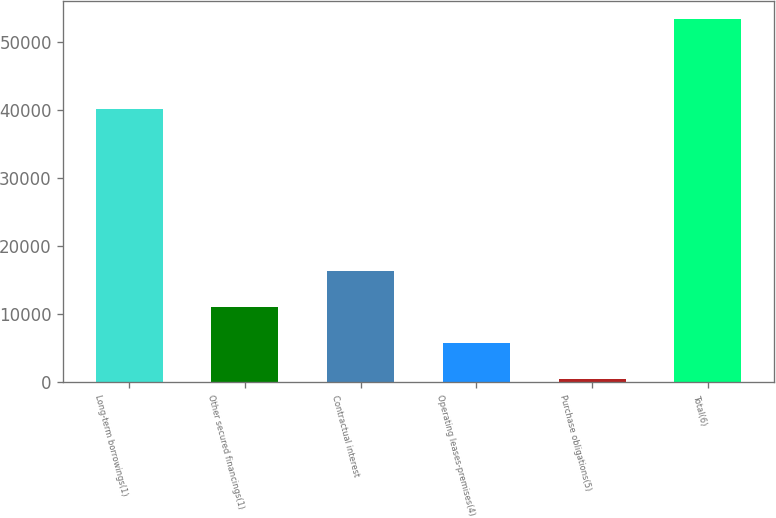<chart> <loc_0><loc_0><loc_500><loc_500><bar_chart><fcel>Long-term borrowings(1)<fcel>Other secured financings(1)<fcel>Contractual interest<fcel>Operating leases-premises(4)<fcel>Purchase obligations(5)<fcel>Total(6)<nl><fcel>40203<fcel>11022.2<fcel>16314.3<fcel>5730.1<fcel>438<fcel>53359<nl></chart> 